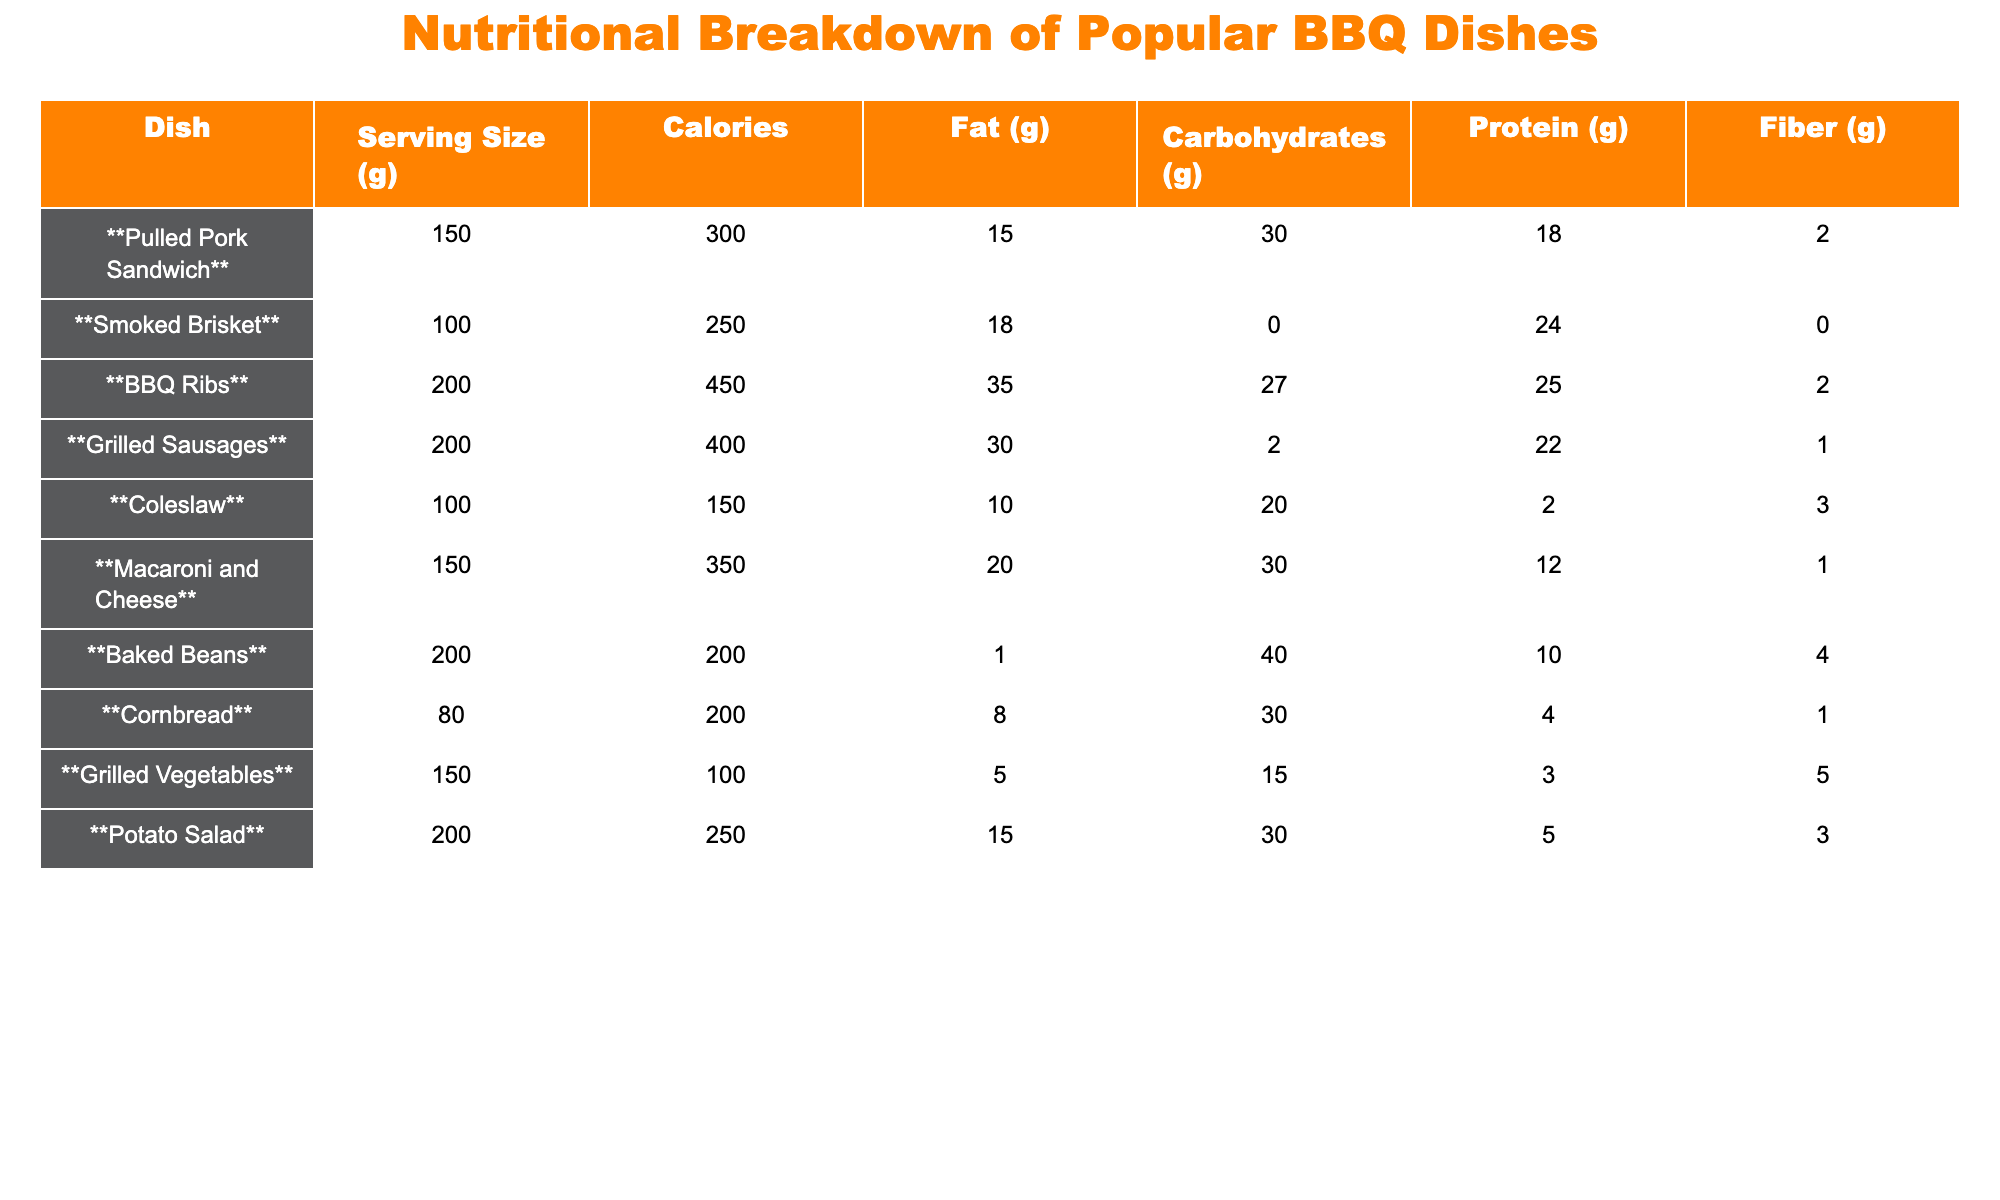What is the calorie count of the Pulled Pork Sandwich? The table shows the calorie count for the Pulled Pork Sandwich listed under the "Calories" column. The value given is 300.
Answer: 300 Which dish has the highest fat content? By observing the "Fat (g)" column, BBQ Ribs has the highest value of 35g compared to all other dishes in the table.
Answer: BBQ Ribs What is the total protein content of a Smoked Brisket and a Grilled Sausages? The protein content of the Smoked Brisket is 24g and for Grilled Sausages, it’s 22g. We add these values: 24 + 22 = 46g.
Answer: 46 Is there more fiber in the Macaroni and Cheese than in the Coleslaw? The Macaroni and Cheese has 1g of fiber, while the Coleslaw has 3g of fiber. Since 1g is less than 3g, the answer is no.
Answer: No What is the average amount of carbohydrates in the BBQ Ribs, Grilled Sausages, and Baked Beans? The carbohydrates content for BBQ Ribs is 27g, Grilled Sausages is 2g, and Baked Beans is 40g. We calculate the total: 27 + 2 + 40 = 69g. There are 3 dishes, so the average is 69g / 3 = 23g.
Answer: 23 How many dishes contain more than 20g of carbohydrates? Looking at the "Carbohydrates (g)" column, the dishes with more than 20g of carbohydrates are BBQ Ribs (27g), Macaroni and Cheese (30g), Baked Beans (40g), and Cornbread (30g). Hence, there are 4 such dishes.
Answer: 4 Which dish has the lowest calorie count? Checking the "Calories" column, Grilled Vegetables has the lowest calorie count listed as 100.
Answer: Grilled Vegetables Is the total fat in Coleslaw and Potato Salad less than the fat in Grilled Sausages? The fat in Coleslaw is 10g and in Potato Salad is 15g, totaling 10 + 15 = 25g. The fat in Grilled Sausages is 30g. Since 25g is less than 30g, the answer is yes.
Answer: Yes What is the difference in calories between the BBQ Ribs and the Pulled Pork Sandwich? The calories in BBQ Ribs are 450 and in Pulled Pork Sandwich are 300. The difference is 450 - 300 = 150 calories.
Answer: 150 How much fiber is found in total across all dishes listed? The fiber values are: Pulled Pork Sandwich (2g), Smoked Brisket (0g), BBQ Ribs (2g), Grilled Sausages (1g), Coleslaw (3g), Macaroni and Cheese (1g), Baked Beans (4g), Cornbread (1g), Grilled Vegetables (5g), Potato Salad (3g). Summing these gives: 2 + 0 + 2 + 1 + 3 + 1 + 4 + 1 + 5 + 3 = 22g of fiber in total.
Answer: 22 